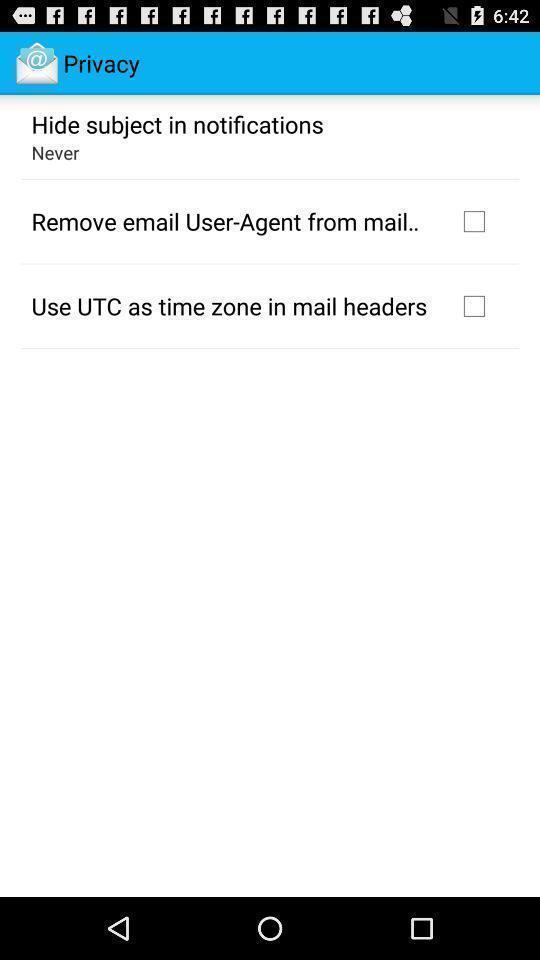Summarize the information in this screenshot. Screen shows privacy settings. 